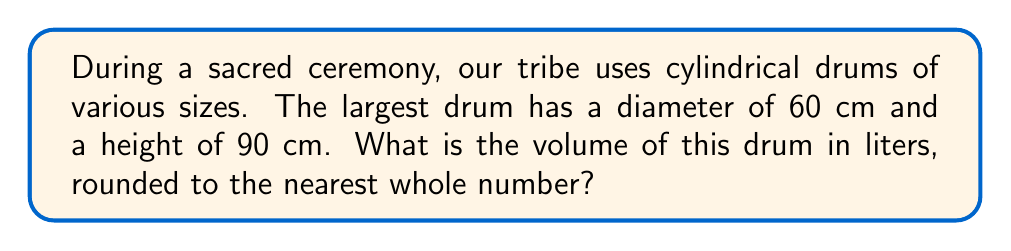Help me with this question. To find the volume of the cylindrical drum, we'll follow these steps:

1. Recall the formula for the volume of a cylinder:
   $$V = \pi r^2 h$$
   where $V$ is volume, $r$ is radius, and $h$ is height.

2. Given information:
   Diameter = 60 cm
   Height = 90 cm

3. Calculate the radius:
   $$r = \frac{\text{diameter}}{2} = \frac{60}{2} = 30 \text{ cm}$$

4. Substitute values into the volume formula:
   $$V = \pi (30\text{ cm})^2 (90\text{ cm})$$

5. Calculate:
   $$V = \pi (900\text{ cm}^2) (90\text{ cm}) = 254,469.00\text{ cm}^3$$

6. Convert cubic centimeters to liters:
   $$254,469.00\text{ cm}^3 \times \frac{1\text{ L}}{1000\text{ cm}^3} = 254.47\text{ L}$$

7. Round to the nearest whole number:
   254.47 L ≈ 254 L

[asy]
import geometry;

size(200);
real r = 3;
real h = 4.5;

path p = (r,0)--(r,h)--(-r,h)--(-r,0);
path q = ellipse((0,0),r,r/4);
path s = ellipse((0,h),r,r/4);

draw(surface(p,q,s),lightgray);
draw(p,thick());
draw(q);
draw(s);

label("60 cm", (r,0), E);
label("90 cm", (r,h/2), E);

dot((0,0), red);
dot((0,h), red);
</asy]
Answer: 254 L 